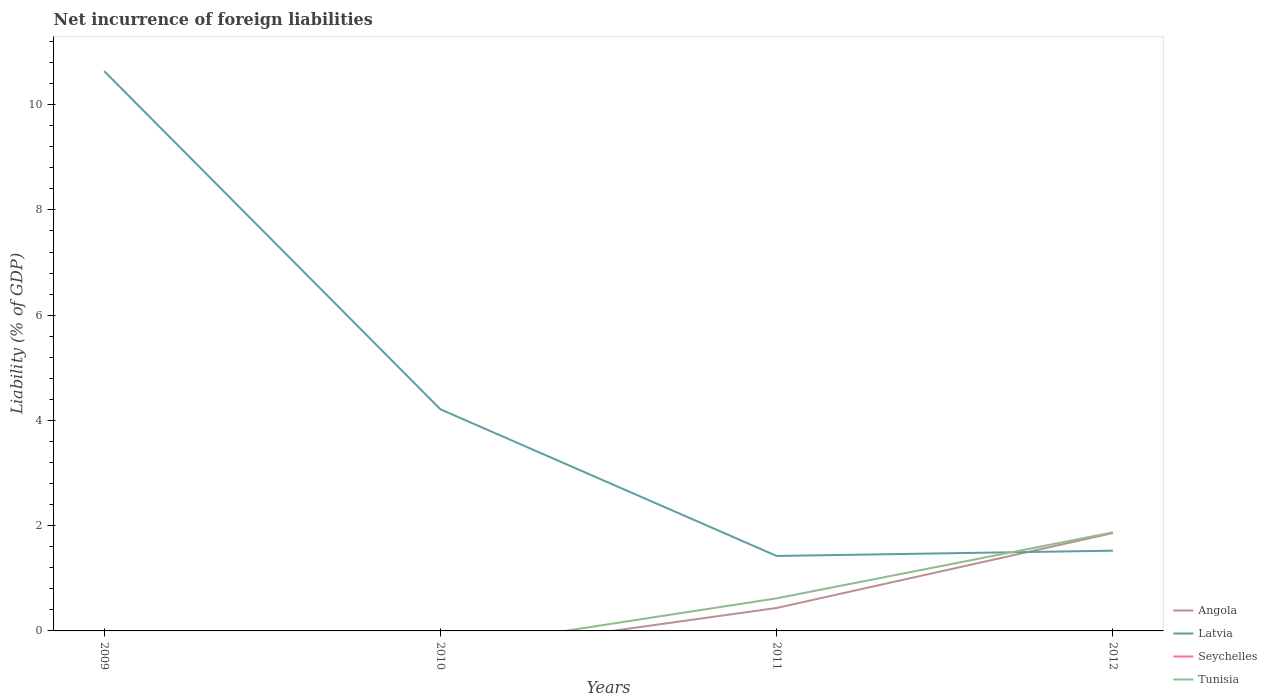How many different coloured lines are there?
Offer a terse response. 3. Is the number of lines equal to the number of legend labels?
Ensure brevity in your answer.  No. Across all years, what is the maximum net incurrence of foreign liabilities in Tunisia?
Keep it short and to the point. 0. What is the total net incurrence of foreign liabilities in Angola in the graph?
Your response must be concise. -1.42. What is the difference between the highest and the second highest net incurrence of foreign liabilities in Latvia?
Give a very brief answer. 9.21. What is the difference between the highest and the lowest net incurrence of foreign liabilities in Tunisia?
Provide a succinct answer. 1. Is the net incurrence of foreign liabilities in Seychelles strictly greater than the net incurrence of foreign liabilities in Tunisia over the years?
Your answer should be very brief. Yes. How many years are there in the graph?
Your answer should be very brief. 4. What is the difference between two consecutive major ticks on the Y-axis?
Your answer should be very brief. 2. Does the graph contain any zero values?
Offer a terse response. Yes. Does the graph contain grids?
Keep it short and to the point. No. How many legend labels are there?
Your answer should be very brief. 4. How are the legend labels stacked?
Make the answer very short. Vertical. What is the title of the graph?
Keep it short and to the point. Net incurrence of foreign liabilities. What is the label or title of the Y-axis?
Your response must be concise. Liability (% of GDP). What is the Liability (% of GDP) in Angola in 2009?
Your answer should be very brief. 0. What is the Liability (% of GDP) of Latvia in 2009?
Ensure brevity in your answer.  10.64. What is the Liability (% of GDP) of Latvia in 2010?
Ensure brevity in your answer.  4.21. What is the Liability (% of GDP) of Tunisia in 2010?
Offer a very short reply. 0. What is the Liability (% of GDP) of Angola in 2011?
Offer a terse response. 0.44. What is the Liability (% of GDP) in Latvia in 2011?
Offer a very short reply. 1.42. What is the Liability (% of GDP) in Tunisia in 2011?
Offer a very short reply. 0.62. What is the Liability (% of GDP) of Angola in 2012?
Your answer should be very brief. 1.86. What is the Liability (% of GDP) of Latvia in 2012?
Your response must be concise. 1.52. What is the Liability (% of GDP) in Seychelles in 2012?
Provide a succinct answer. 0. What is the Liability (% of GDP) of Tunisia in 2012?
Your response must be concise. 1.87. Across all years, what is the maximum Liability (% of GDP) in Angola?
Your response must be concise. 1.86. Across all years, what is the maximum Liability (% of GDP) of Latvia?
Ensure brevity in your answer.  10.64. Across all years, what is the maximum Liability (% of GDP) of Tunisia?
Offer a terse response. 1.87. Across all years, what is the minimum Liability (% of GDP) of Angola?
Keep it short and to the point. 0. Across all years, what is the minimum Liability (% of GDP) in Latvia?
Keep it short and to the point. 1.42. What is the total Liability (% of GDP) of Angola in the graph?
Make the answer very short. 2.3. What is the total Liability (% of GDP) of Latvia in the graph?
Provide a succinct answer. 17.8. What is the total Liability (% of GDP) of Seychelles in the graph?
Your answer should be compact. 0. What is the total Liability (% of GDP) in Tunisia in the graph?
Give a very brief answer. 2.49. What is the difference between the Liability (% of GDP) of Latvia in 2009 and that in 2010?
Your answer should be very brief. 6.43. What is the difference between the Liability (% of GDP) of Latvia in 2009 and that in 2011?
Make the answer very short. 9.21. What is the difference between the Liability (% of GDP) of Latvia in 2009 and that in 2012?
Your response must be concise. 9.11. What is the difference between the Liability (% of GDP) of Latvia in 2010 and that in 2011?
Offer a very short reply. 2.79. What is the difference between the Liability (% of GDP) in Latvia in 2010 and that in 2012?
Offer a very short reply. 2.69. What is the difference between the Liability (% of GDP) of Angola in 2011 and that in 2012?
Ensure brevity in your answer.  -1.42. What is the difference between the Liability (% of GDP) in Latvia in 2011 and that in 2012?
Provide a succinct answer. -0.1. What is the difference between the Liability (% of GDP) in Tunisia in 2011 and that in 2012?
Offer a very short reply. -1.25. What is the difference between the Liability (% of GDP) in Latvia in 2009 and the Liability (% of GDP) in Tunisia in 2011?
Ensure brevity in your answer.  10.02. What is the difference between the Liability (% of GDP) in Latvia in 2009 and the Liability (% of GDP) in Tunisia in 2012?
Offer a terse response. 8.77. What is the difference between the Liability (% of GDP) in Latvia in 2010 and the Liability (% of GDP) in Tunisia in 2011?
Your response must be concise. 3.59. What is the difference between the Liability (% of GDP) of Latvia in 2010 and the Liability (% of GDP) of Tunisia in 2012?
Provide a short and direct response. 2.34. What is the difference between the Liability (% of GDP) of Angola in 2011 and the Liability (% of GDP) of Latvia in 2012?
Offer a terse response. -1.09. What is the difference between the Liability (% of GDP) in Angola in 2011 and the Liability (% of GDP) in Tunisia in 2012?
Your answer should be compact. -1.44. What is the difference between the Liability (% of GDP) of Latvia in 2011 and the Liability (% of GDP) of Tunisia in 2012?
Offer a terse response. -0.45. What is the average Liability (% of GDP) in Angola per year?
Your answer should be compact. 0.57. What is the average Liability (% of GDP) in Latvia per year?
Offer a very short reply. 4.45. What is the average Liability (% of GDP) in Tunisia per year?
Provide a short and direct response. 0.62. In the year 2011, what is the difference between the Liability (% of GDP) in Angola and Liability (% of GDP) in Latvia?
Ensure brevity in your answer.  -0.99. In the year 2011, what is the difference between the Liability (% of GDP) in Angola and Liability (% of GDP) in Tunisia?
Offer a very short reply. -0.18. In the year 2011, what is the difference between the Liability (% of GDP) in Latvia and Liability (% of GDP) in Tunisia?
Your answer should be very brief. 0.81. In the year 2012, what is the difference between the Liability (% of GDP) in Angola and Liability (% of GDP) in Latvia?
Make the answer very short. 0.34. In the year 2012, what is the difference between the Liability (% of GDP) in Angola and Liability (% of GDP) in Tunisia?
Keep it short and to the point. -0.01. In the year 2012, what is the difference between the Liability (% of GDP) of Latvia and Liability (% of GDP) of Tunisia?
Your answer should be very brief. -0.35. What is the ratio of the Liability (% of GDP) of Latvia in 2009 to that in 2010?
Provide a succinct answer. 2.53. What is the ratio of the Liability (% of GDP) in Latvia in 2009 to that in 2011?
Your response must be concise. 7.47. What is the ratio of the Liability (% of GDP) of Latvia in 2009 to that in 2012?
Make the answer very short. 6.98. What is the ratio of the Liability (% of GDP) in Latvia in 2010 to that in 2011?
Keep it short and to the point. 2.96. What is the ratio of the Liability (% of GDP) of Latvia in 2010 to that in 2012?
Provide a succinct answer. 2.76. What is the ratio of the Liability (% of GDP) in Angola in 2011 to that in 2012?
Offer a very short reply. 0.23. What is the ratio of the Liability (% of GDP) of Latvia in 2011 to that in 2012?
Your answer should be compact. 0.93. What is the ratio of the Liability (% of GDP) of Tunisia in 2011 to that in 2012?
Ensure brevity in your answer.  0.33. What is the difference between the highest and the second highest Liability (% of GDP) in Latvia?
Offer a very short reply. 6.43. What is the difference between the highest and the lowest Liability (% of GDP) in Angola?
Ensure brevity in your answer.  1.86. What is the difference between the highest and the lowest Liability (% of GDP) in Latvia?
Offer a very short reply. 9.21. What is the difference between the highest and the lowest Liability (% of GDP) in Tunisia?
Provide a short and direct response. 1.87. 